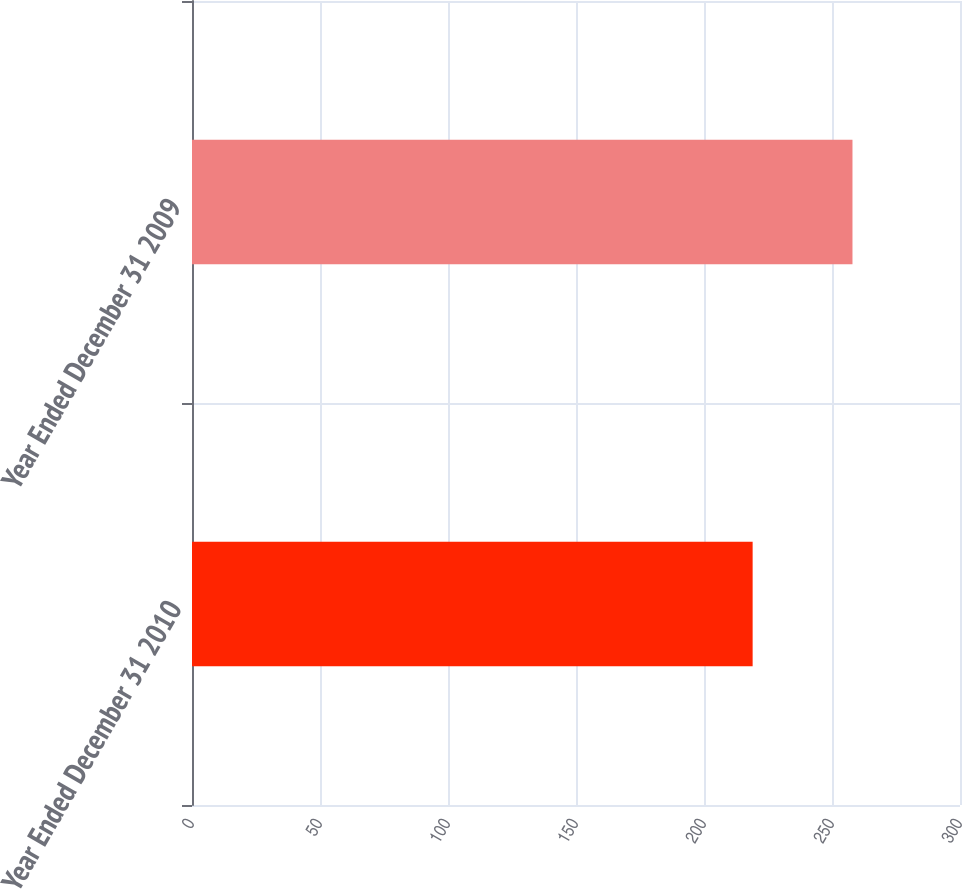Convert chart to OTSL. <chart><loc_0><loc_0><loc_500><loc_500><bar_chart><fcel>Year Ended December 31 2010<fcel>Year Ended December 31 2009<nl><fcel>219<fcel>258<nl></chart> 